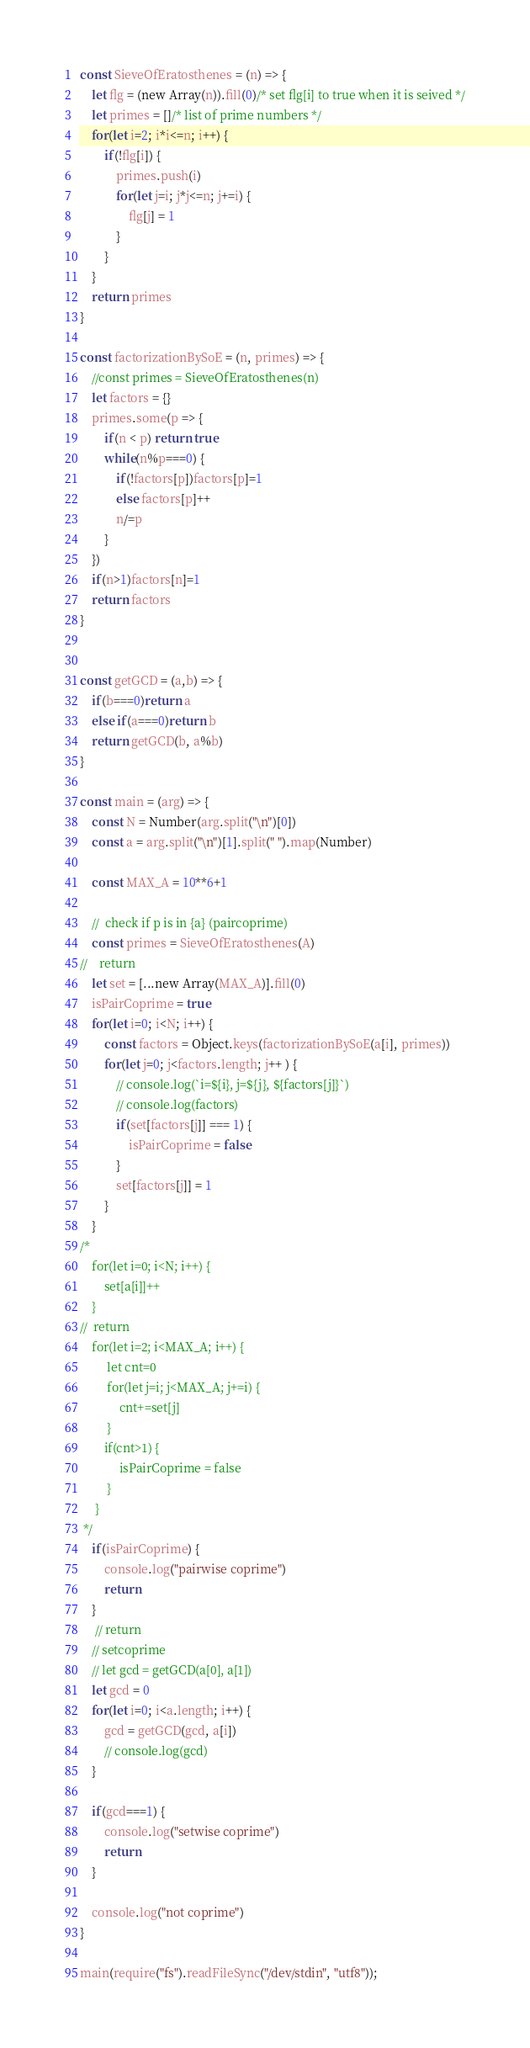<code> <loc_0><loc_0><loc_500><loc_500><_JavaScript_>const SieveOfEratosthenes = (n) => {
    let flg = (new Array(n)).fill(0)/* set flg[i] to true when it is seived */
    let primes = []/* list of prime numbers */
    for(let i=2; i*i<=n; i++) {
        if(!flg[i]) {
            primes.push(i)
            for(let j=i; j*j<=n; j+=i) {
                flg[j] = 1
            }
        }
    }
    return primes
}

const factorizationBySoE = (n, primes) => {
    //const primes = SieveOfEratosthenes(n)
    let factors = {}
    primes.some(p => {
        if(n < p) return true
        while(n%p===0) {
            if(!factors[p])factors[p]=1
            else factors[p]++
            n/=p
        }
    })
    if(n>1)factors[n]=1
    return factors
}


const getGCD = (a,b) => {
    if(b===0)return a
    else if(a===0)return b
    return getGCD(b, a%b)
}

const main = (arg) => {
    const N = Number(arg.split("\n")[0])
    const a = arg.split("\n")[1].split(" ").map(Number)
    
    const MAX_A = 10**6+1
    
    //  check if p is in {a} (paircoprime)
    const primes = SieveOfEratosthenes(A)
//    return
    let set = [...new Array(MAX_A)].fill(0)
    isPairCoprime = true
    for(let i=0; i<N; i++) {
        const factors = Object.keys(factorizationBySoE(a[i], primes))
        for(let j=0; j<factors.length; j++ ) {
            // console.log(`i=${i}, j=${j}, ${factors[j]}`)
            // console.log(factors)
            if(set[factors[j]] === 1) {
                isPairCoprime = false
            }
            set[factors[j]] = 1
        }
    }
/*
    for(let i=0; i<N; i++) {
        set[a[i]]++
    }
//  return
    for(let i=2; i<MAX_A; i++) {
         let cnt=0
         for(let j=i; j<MAX_A; j+=i) {
             cnt+=set[j]
         }
        if(cnt>1) {
             isPairCoprime = false
         }
     }
 */
    if(isPairCoprime) {
        console.log("pairwise coprime")
        return
    }
     // return
    // setcoprime
    // let gcd = getGCD(a[0], a[1])
    let gcd = 0
    for(let i=0; i<a.length; i++) {
        gcd = getGCD(gcd, a[i])
        // console.log(gcd)
    }
    
    if(gcd===1) {
        console.log("setwise coprime")
        return
    }
    
    console.log("not coprime")
}

main(require("fs").readFileSync("/dev/stdin", "utf8"));
</code> 